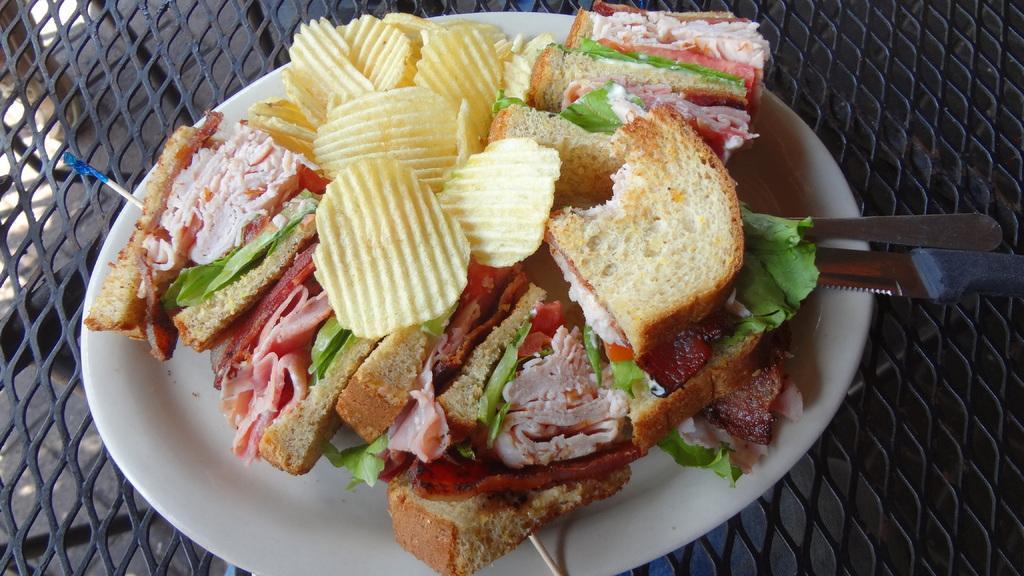Could you give a brief overview of what you see in this image? In this image we can see a plate with some food, spoon and a knife on an object, which looks like a table. 